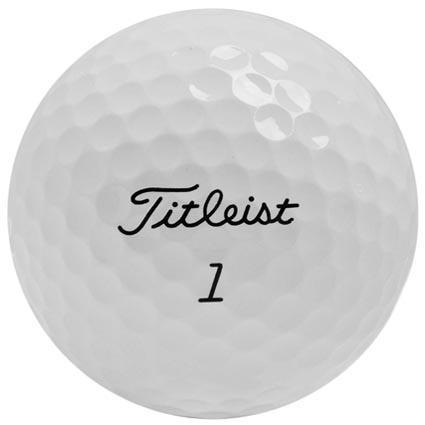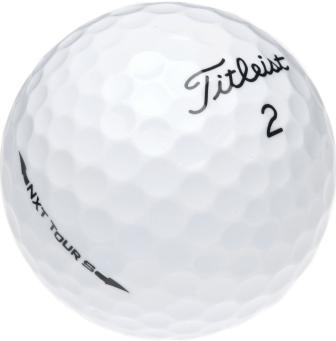The first image is the image on the left, the second image is the image on the right. For the images shown, is this caption "There are exactly two golf balls" true? Answer yes or no. Yes. 